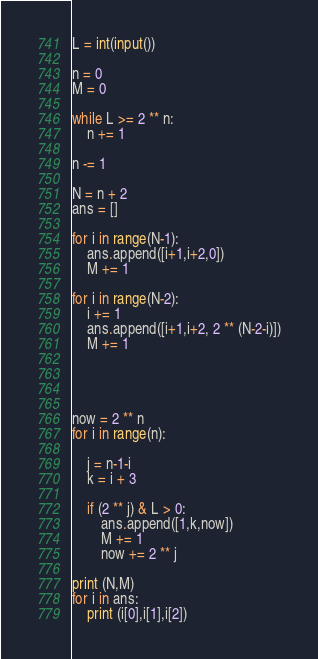Convert code to text. <code><loc_0><loc_0><loc_500><loc_500><_Python_>
L = int(input())

n = 0
M = 0

while L >= 2 ** n:
    n += 1

n -= 1

N = n + 2
ans = []

for i in range(N-1):
    ans.append([i+1,i+2,0])
    M += 1

for i in range(N-2):
    i += 1
    ans.append([i+1,i+2, 2 ** (N-2-i)])
    M += 1




now = 2 ** n
for i in range(n):

    j = n-1-i
    k = i + 3
    
    if (2 ** j) & L > 0:
        ans.append([1,k,now])
        M += 1
        now += 2 ** j

print (N,M)
for i in ans:
    print (i[0],i[1],i[2])
</code> 